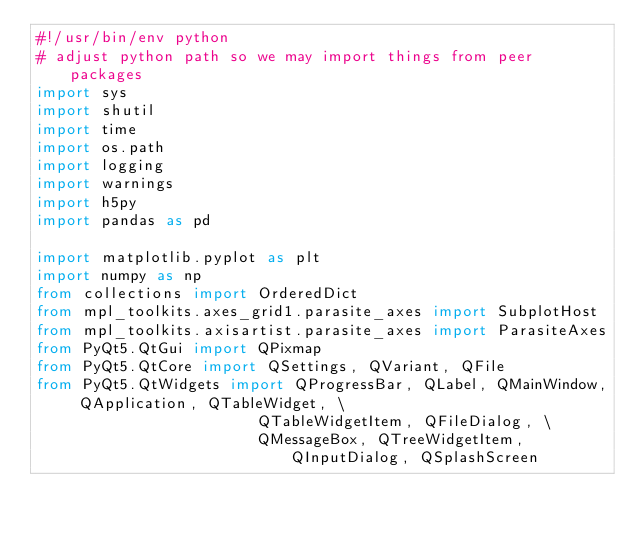<code> <loc_0><loc_0><loc_500><loc_500><_Python_>#!/usr/bin/env python
# adjust python path so we may import things from peer packages
import sys
import shutil
import time
import os.path
import logging
import warnings
import h5py
import pandas as pd

import matplotlib.pyplot as plt
import numpy as np
from collections import OrderedDict
from mpl_toolkits.axes_grid1.parasite_axes import SubplotHost
from mpl_toolkits.axisartist.parasite_axes import ParasiteAxes
from PyQt5.QtGui import QPixmap
from PyQt5.QtCore import QSettings, QVariant, QFile
from PyQt5.QtWidgets import QProgressBar, QLabel, QMainWindow, QApplication, QTableWidget, \
                        QTableWidgetItem, QFileDialog, \
                        QMessageBox, QTreeWidgetItem, QInputDialog, QSplashScreen
</code> 